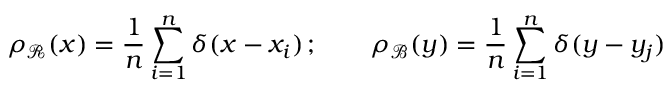Convert formula to latex. <formula><loc_0><loc_0><loc_500><loc_500>\rho _ { \mathcal { R } } ( x ) = \frac { 1 } { n } \sum _ { i = 1 } ^ { n } \delta ( x - x _ { i } ) \, ; \quad \rho _ { \mathcal { B } } ( y ) = \frac { 1 } { n } \sum _ { i = 1 } ^ { n } \delta ( y - y _ { j } )</formula> 